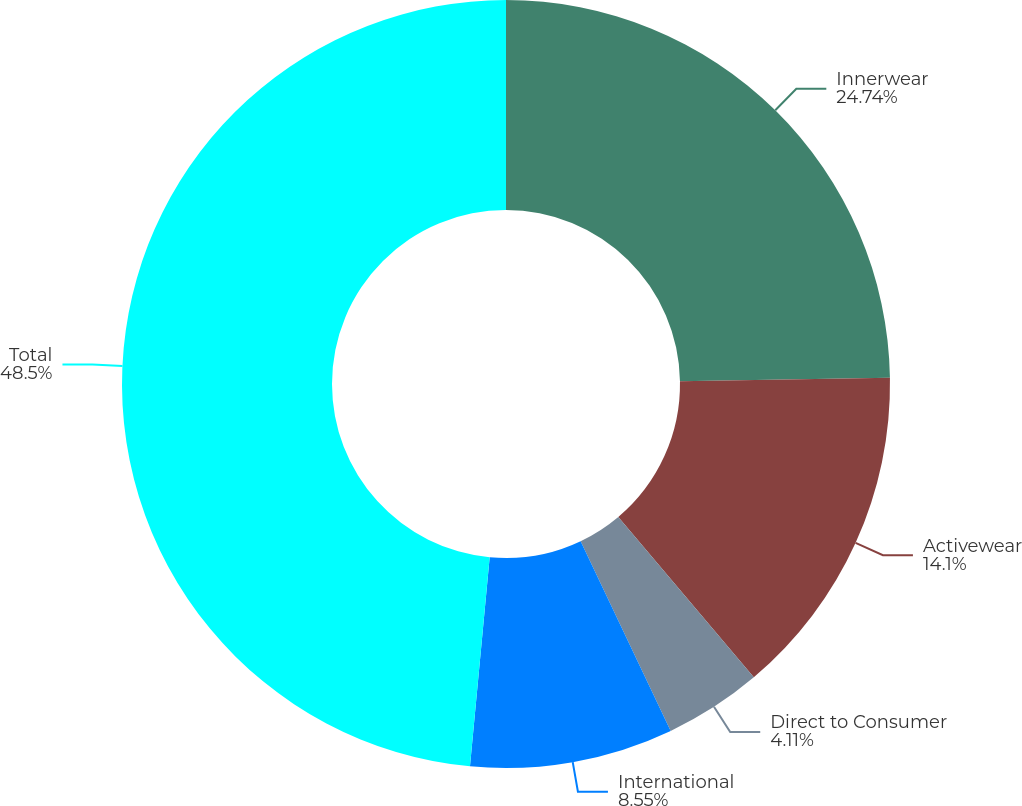<chart> <loc_0><loc_0><loc_500><loc_500><pie_chart><fcel>Innerwear<fcel>Activewear<fcel>Direct to Consumer<fcel>International<fcel>Total<nl><fcel>24.74%<fcel>14.1%<fcel>4.11%<fcel>8.55%<fcel>48.51%<nl></chart> 